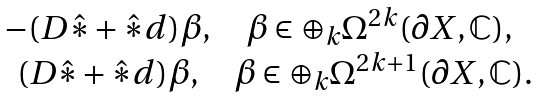Convert formula to latex. <formula><loc_0><loc_0><loc_500><loc_500>\begin{matrix} - ( D \hat { * } + \hat { * } d ) \beta , \quad \beta \in \oplus _ { k } \Omega ^ { 2 k } ( \partial X , \mathbb { C } ) , \\ \quad ( D \hat { * } + \hat { * } d ) \beta , \quad \beta \in \oplus _ { k } \Omega ^ { 2 k + 1 } ( \partial X , \mathbb { C } ) . \end{matrix}</formula> 